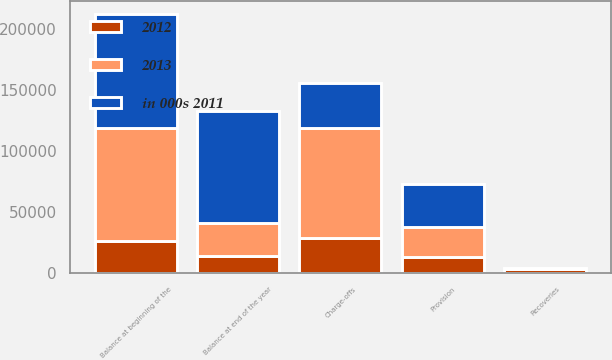<chart> <loc_0><loc_0><loc_500><loc_500><stacked_bar_chart><ecel><fcel>Balance at beginning of the<fcel>Provision<fcel>Recoveries<fcel>Charge-offs<fcel>Balance at end of the year<nl><fcel>2012<fcel>26540<fcel>13283<fcel>3338<fcel>28847<fcel>14314<nl><fcel>2013<fcel>92087<fcel>24075<fcel>292<fcel>89914<fcel>26540<nl><fcel>in 000s 2011<fcel>93535<fcel>35567<fcel>272<fcel>37287<fcel>92087<nl></chart> 